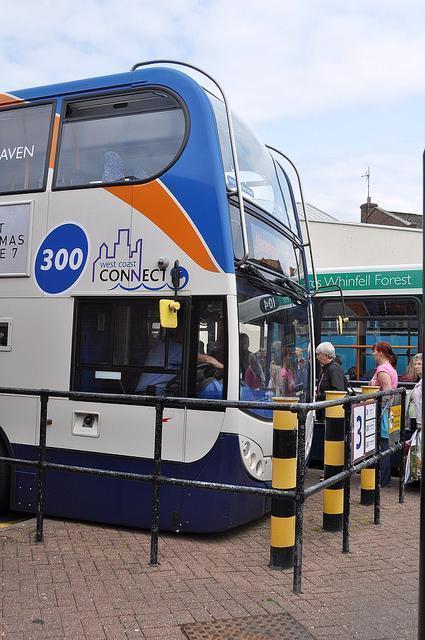The bus in the background is going to the home of which endangered animal?
Pick the right solution, then justify: 'Answer: answer
Rationale: rationale.'
Options: Bald eagle, red squirrel, peregrine falcon, koala. Answer: red squirrel.
Rationale: The bus in the background is from the red squirrel's home. 